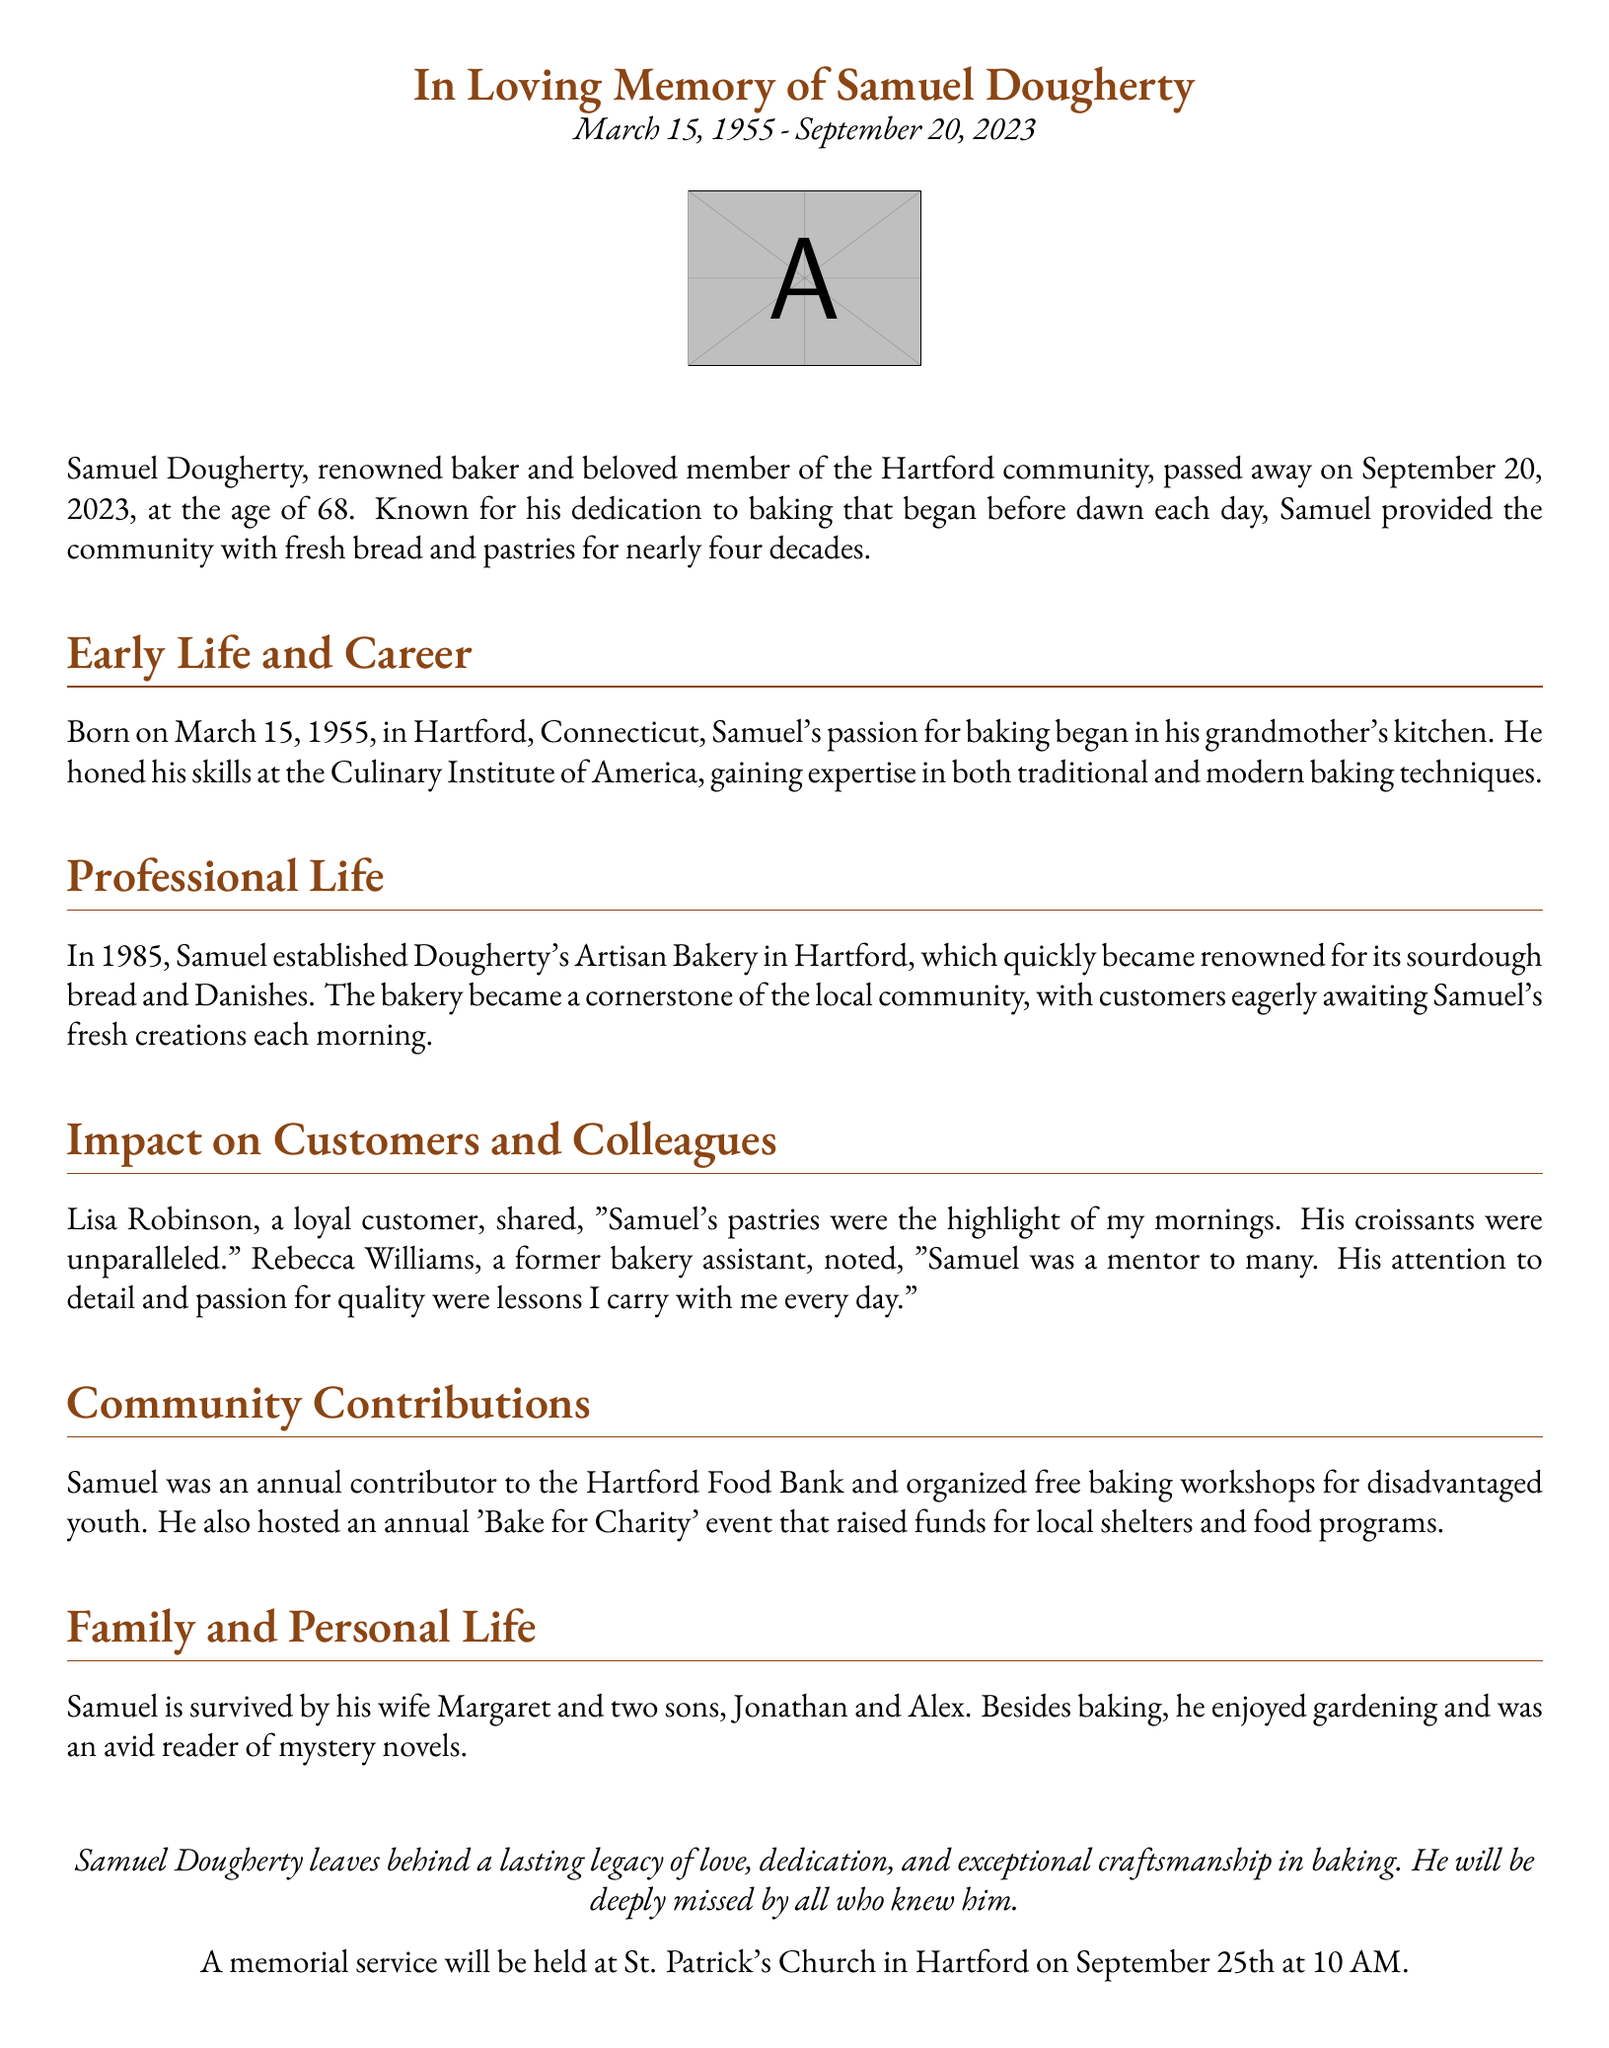What was Samuel Dougherty's occupation? The document states that Samuel Dougherty was a renowned baker.
Answer: Baker When was Samuel Dougherty born? The document specifies that Samuel was born on March 15, 1955.
Answer: March 15, 1955 What year did Samuel establish his bakery? According to the document, Samuel established Dougherty's Artisan Bakery in Hartford in 1985.
Answer: 1985 How many sons did Samuel leave behind? The document mentions that Samuel is survived by two sons.
Answer: Two What type of bread was Dougherty's Artisan Bakery renowned for? The document says that the bakery became renowned for its sourdough bread.
Answer: Sourdough bread What community contribution did Samuel make? The document notes that Samuel was an annual contributor to the Hartford Food Bank.
Answer: Hartford Food Bank Who mentioned that Samuel's croissants were unparalleled? The document attributes the quote about croissants to Lisa Robinson, a loyal customer.
Answer: Lisa Robinson When was the memorial service scheduled? The document states that the memorial service will be held on September 25th at 10 AM.
Answer: September 25th at 10 AM What was Samuel's passion besides baking? The document indicates that Samuel enjoyed gardening besides baking.
Answer: Gardening 